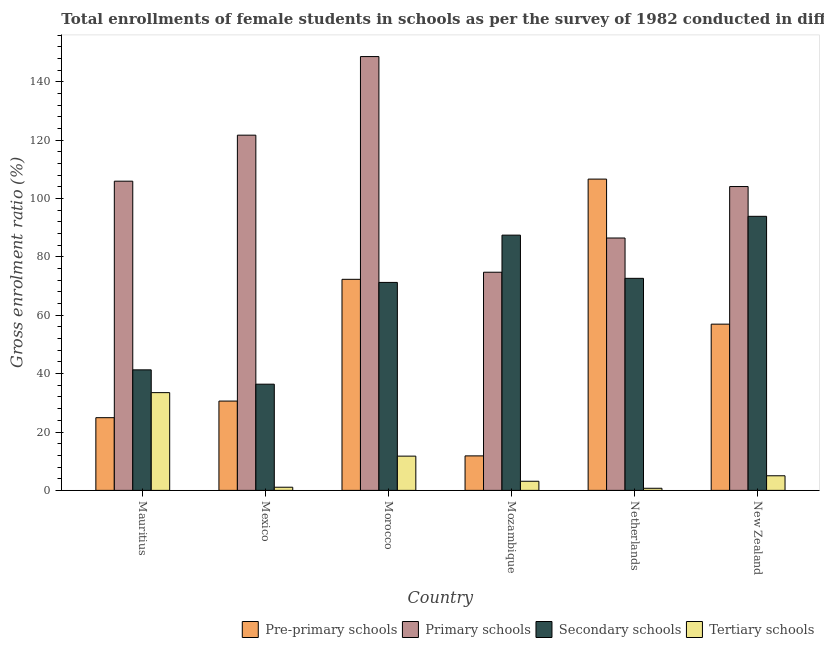How many groups of bars are there?
Offer a terse response. 6. Are the number of bars per tick equal to the number of legend labels?
Offer a very short reply. Yes. Are the number of bars on each tick of the X-axis equal?
Give a very brief answer. Yes. How many bars are there on the 6th tick from the left?
Your answer should be compact. 4. What is the label of the 5th group of bars from the left?
Your answer should be very brief. Netherlands. In how many cases, is the number of bars for a given country not equal to the number of legend labels?
Ensure brevity in your answer.  0. What is the gross enrolment ratio(female) in pre-primary schools in New Zealand?
Your answer should be compact. 56.95. Across all countries, what is the maximum gross enrolment ratio(female) in primary schools?
Keep it short and to the point. 148.61. Across all countries, what is the minimum gross enrolment ratio(female) in tertiary schools?
Give a very brief answer. 0.73. In which country was the gross enrolment ratio(female) in secondary schools maximum?
Keep it short and to the point. New Zealand. What is the total gross enrolment ratio(female) in secondary schools in the graph?
Provide a short and direct response. 402.89. What is the difference between the gross enrolment ratio(female) in secondary schools in Morocco and that in Netherlands?
Your answer should be compact. -1.4. What is the difference between the gross enrolment ratio(female) in secondary schools in New Zealand and the gross enrolment ratio(female) in tertiary schools in Mauritius?
Keep it short and to the point. 60.4. What is the average gross enrolment ratio(female) in pre-primary schools per country?
Offer a very short reply. 50.54. What is the difference between the gross enrolment ratio(female) in pre-primary schools and gross enrolment ratio(female) in tertiary schools in Mauritius?
Offer a very short reply. -8.58. What is the ratio of the gross enrolment ratio(female) in tertiary schools in Morocco to that in Netherlands?
Offer a very short reply. 16.17. Is the gross enrolment ratio(female) in secondary schools in Netherlands less than that in New Zealand?
Offer a very short reply. Yes. Is the difference between the gross enrolment ratio(female) in tertiary schools in Netherlands and New Zealand greater than the difference between the gross enrolment ratio(female) in secondary schools in Netherlands and New Zealand?
Keep it short and to the point. Yes. What is the difference between the highest and the second highest gross enrolment ratio(female) in pre-primary schools?
Your response must be concise. 34.33. What is the difference between the highest and the lowest gross enrolment ratio(female) in primary schools?
Make the answer very short. 73.88. Is the sum of the gross enrolment ratio(female) in primary schools in Mexico and Mozambique greater than the maximum gross enrolment ratio(female) in tertiary schools across all countries?
Keep it short and to the point. Yes. What does the 1st bar from the left in Mozambique represents?
Give a very brief answer. Pre-primary schools. What does the 1st bar from the right in New Zealand represents?
Ensure brevity in your answer.  Tertiary schools. Is it the case that in every country, the sum of the gross enrolment ratio(female) in pre-primary schools and gross enrolment ratio(female) in primary schools is greater than the gross enrolment ratio(female) in secondary schools?
Offer a terse response. No. How many countries are there in the graph?
Give a very brief answer. 6. Does the graph contain any zero values?
Offer a terse response. No. How many legend labels are there?
Provide a succinct answer. 4. How are the legend labels stacked?
Keep it short and to the point. Horizontal. What is the title of the graph?
Ensure brevity in your answer.  Total enrollments of female students in schools as per the survey of 1982 conducted in different countries. What is the Gross enrolment ratio (%) in Pre-primary schools in Mauritius?
Your response must be concise. 24.91. What is the Gross enrolment ratio (%) of Primary schools in Mauritius?
Your response must be concise. 105.93. What is the Gross enrolment ratio (%) in Secondary schools in Mauritius?
Make the answer very short. 41.29. What is the Gross enrolment ratio (%) of Tertiary schools in Mauritius?
Your answer should be very brief. 33.49. What is the Gross enrolment ratio (%) of Pre-primary schools in Mexico?
Your answer should be compact. 30.6. What is the Gross enrolment ratio (%) in Primary schools in Mexico?
Provide a short and direct response. 121.69. What is the Gross enrolment ratio (%) of Secondary schools in Mexico?
Your answer should be compact. 36.38. What is the Gross enrolment ratio (%) in Tertiary schools in Mexico?
Your answer should be very brief. 1.08. What is the Gross enrolment ratio (%) of Pre-primary schools in Morocco?
Your answer should be very brief. 72.31. What is the Gross enrolment ratio (%) in Primary schools in Morocco?
Offer a terse response. 148.61. What is the Gross enrolment ratio (%) of Secondary schools in Morocco?
Offer a terse response. 71.25. What is the Gross enrolment ratio (%) of Tertiary schools in Morocco?
Provide a succinct answer. 11.73. What is the Gross enrolment ratio (%) of Pre-primary schools in Mozambique?
Make the answer very short. 11.82. What is the Gross enrolment ratio (%) in Primary schools in Mozambique?
Make the answer very short. 74.73. What is the Gross enrolment ratio (%) of Secondary schools in Mozambique?
Offer a terse response. 87.44. What is the Gross enrolment ratio (%) in Tertiary schools in Mozambique?
Provide a short and direct response. 3.13. What is the Gross enrolment ratio (%) of Pre-primary schools in Netherlands?
Provide a succinct answer. 106.64. What is the Gross enrolment ratio (%) of Primary schools in Netherlands?
Your answer should be very brief. 86.46. What is the Gross enrolment ratio (%) of Secondary schools in Netherlands?
Provide a short and direct response. 72.64. What is the Gross enrolment ratio (%) of Tertiary schools in Netherlands?
Provide a short and direct response. 0.73. What is the Gross enrolment ratio (%) in Pre-primary schools in New Zealand?
Provide a short and direct response. 56.95. What is the Gross enrolment ratio (%) in Primary schools in New Zealand?
Offer a terse response. 104.09. What is the Gross enrolment ratio (%) in Secondary schools in New Zealand?
Offer a terse response. 93.89. What is the Gross enrolment ratio (%) in Tertiary schools in New Zealand?
Keep it short and to the point. 5.01. Across all countries, what is the maximum Gross enrolment ratio (%) of Pre-primary schools?
Your response must be concise. 106.64. Across all countries, what is the maximum Gross enrolment ratio (%) of Primary schools?
Your response must be concise. 148.61. Across all countries, what is the maximum Gross enrolment ratio (%) in Secondary schools?
Keep it short and to the point. 93.89. Across all countries, what is the maximum Gross enrolment ratio (%) in Tertiary schools?
Your response must be concise. 33.49. Across all countries, what is the minimum Gross enrolment ratio (%) in Pre-primary schools?
Ensure brevity in your answer.  11.82. Across all countries, what is the minimum Gross enrolment ratio (%) of Primary schools?
Provide a succinct answer. 74.73. Across all countries, what is the minimum Gross enrolment ratio (%) in Secondary schools?
Provide a short and direct response. 36.38. Across all countries, what is the minimum Gross enrolment ratio (%) in Tertiary schools?
Keep it short and to the point. 0.73. What is the total Gross enrolment ratio (%) in Pre-primary schools in the graph?
Provide a succinct answer. 303.22. What is the total Gross enrolment ratio (%) of Primary schools in the graph?
Provide a short and direct response. 641.52. What is the total Gross enrolment ratio (%) of Secondary schools in the graph?
Make the answer very short. 402.89. What is the total Gross enrolment ratio (%) in Tertiary schools in the graph?
Keep it short and to the point. 55.17. What is the difference between the Gross enrolment ratio (%) in Pre-primary schools in Mauritius and that in Mexico?
Your answer should be compact. -5.69. What is the difference between the Gross enrolment ratio (%) in Primary schools in Mauritius and that in Mexico?
Your response must be concise. -15.76. What is the difference between the Gross enrolment ratio (%) in Secondary schools in Mauritius and that in Mexico?
Make the answer very short. 4.91. What is the difference between the Gross enrolment ratio (%) of Tertiary schools in Mauritius and that in Mexico?
Provide a short and direct response. 32.41. What is the difference between the Gross enrolment ratio (%) of Pre-primary schools in Mauritius and that in Morocco?
Provide a succinct answer. -47.4. What is the difference between the Gross enrolment ratio (%) of Primary schools in Mauritius and that in Morocco?
Offer a terse response. -42.69. What is the difference between the Gross enrolment ratio (%) in Secondary schools in Mauritius and that in Morocco?
Your response must be concise. -29.95. What is the difference between the Gross enrolment ratio (%) in Tertiary schools in Mauritius and that in Morocco?
Ensure brevity in your answer.  21.75. What is the difference between the Gross enrolment ratio (%) in Pre-primary schools in Mauritius and that in Mozambique?
Your answer should be compact. 13.09. What is the difference between the Gross enrolment ratio (%) in Primary schools in Mauritius and that in Mozambique?
Offer a very short reply. 31.19. What is the difference between the Gross enrolment ratio (%) in Secondary schools in Mauritius and that in Mozambique?
Your answer should be compact. -46.15. What is the difference between the Gross enrolment ratio (%) of Tertiary schools in Mauritius and that in Mozambique?
Your response must be concise. 30.36. What is the difference between the Gross enrolment ratio (%) of Pre-primary schools in Mauritius and that in Netherlands?
Keep it short and to the point. -81.73. What is the difference between the Gross enrolment ratio (%) of Primary schools in Mauritius and that in Netherlands?
Provide a succinct answer. 19.47. What is the difference between the Gross enrolment ratio (%) of Secondary schools in Mauritius and that in Netherlands?
Give a very brief answer. -31.35. What is the difference between the Gross enrolment ratio (%) of Tertiary schools in Mauritius and that in Netherlands?
Give a very brief answer. 32.76. What is the difference between the Gross enrolment ratio (%) of Pre-primary schools in Mauritius and that in New Zealand?
Offer a terse response. -32.04. What is the difference between the Gross enrolment ratio (%) of Primary schools in Mauritius and that in New Zealand?
Provide a succinct answer. 1.84. What is the difference between the Gross enrolment ratio (%) of Secondary schools in Mauritius and that in New Zealand?
Give a very brief answer. -52.59. What is the difference between the Gross enrolment ratio (%) of Tertiary schools in Mauritius and that in New Zealand?
Offer a very short reply. 28.48. What is the difference between the Gross enrolment ratio (%) of Pre-primary schools in Mexico and that in Morocco?
Give a very brief answer. -41.71. What is the difference between the Gross enrolment ratio (%) of Primary schools in Mexico and that in Morocco?
Keep it short and to the point. -26.92. What is the difference between the Gross enrolment ratio (%) of Secondary schools in Mexico and that in Morocco?
Offer a very short reply. -34.86. What is the difference between the Gross enrolment ratio (%) of Tertiary schools in Mexico and that in Morocco?
Give a very brief answer. -10.65. What is the difference between the Gross enrolment ratio (%) in Pre-primary schools in Mexico and that in Mozambique?
Your response must be concise. 18.77. What is the difference between the Gross enrolment ratio (%) in Primary schools in Mexico and that in Mozambique?
Make the answer very short. 46.96. What is the difference between the Gross enrolment ratio (%) of Secondary schools in Mexico and that in Mozambique?
Offer a terse response. -51.06. What is the difference between the Gross enrolment ratio (%) in Tertiary schools in Mexico and that in Mozambique?
Give a very brief answer. -2.05. What is the difference between the Gross enrolment ratio (%) of Pre-primary schools in Mexico and that in Netherlands?
Keep it short and to the point. -76.04. What is the difference between the Gross enrolment ratio (%) of Primary schools in Mexico and that in Netherlands?
Make the answer very short. 35.24. What is the difference between the Gross enrolment ratio (%) in Secondary schools in Mexico and that in Netherlands?
Give a very brief answer. -36.26. What is the difference between the Gross enrolment ratio (%) of Tertiary schools in Mexico and that in Netherlands?
Ensure brevity in your answer.  0.36. What is the difference between the Gross enrolment ratio (%) in Pre-primary schools in Mexico and that in New Zealand?
Your answer should be very brief. -26.35. What is the difference between the Gross enrolment ratio (%) in Primary schools in Mexico and that in New Zealand?
Give a very brief answer. 17.6. What is the difference between the Gross enrolment ratio (%) of Secondary schools in Mexico and that in New Zealand?
Your answer should be compact. -57.5. What is the difference between the Gross enrolment ratio (%) of Tertiary schools in Mexico and that in New Zealand?
Offer a terse response. -3.93. What is the difference between the Gross enrolment ratio (%) in Pre-primary schools in Morocco and that in Mozambique?
Offer a very short reply. 60.49. What is the difference between the Gross enrolment ratio (%) in Primary schools in Morocco and that in Mozambique?
Provide a succinct answer. 73.88. What is the difference between the Gross enrolment ratio (%) of Secondary schools in Morocco and that in Mozambique?
Give a very brief answer. -16.2. What is the difference between the Gross enrolment ratio (%) in Tertiary schools in Morocco and that in Mozambique?
Keep it short and to the point. 8.6. What is the difference between the Gross enrolment ratio (%) of Pre-primary schools in Morocco and that in Netherlands?
Offer a terse response. -34.33. What is the difference between the Gross enrolment ratio (%) of Primary schools in Morocco and that in Netherlands?
Offer a very short reply. 62.16. What is the difference between the Gross enrolment ratio (%) in Secondary schools in Morocco and that in Netherlands?
Offer a terse response. -1.4. What is the difference between the Gross enrolment ratio (%) of Tertiary schools in Morocco and that in Netherlands?
Provide a succinct answer. 11.01. What is the difference between the Gross enrolment ratio (%) in Pre-primary schools in Morocco and that in New Zealand?
Your response must be concise. 15.36. What is the difference between the Gross enrolment ratio (%) in Primary schools in Morocco and that in New Zealand?
Your response must be concise. 44.52. What is the difference between the Gross enrolment ratio (%) in Secondary schools in Morocco and that in New Zealand?
Ensure brevity in your answer.  -22.64. What is the difference between the Gross enrolment ratio (%) of Tertiary schools in Morocco and that in New Zealand?
Your answer should be very brief. 6.72. What is the difference between the Gross enrolment ratio (%) of Pre-primary schools in Mozambique and that in Netherlands?
Ensure brevity in your answer.  -94.81. What is the difference between the Gross enrolment ratio (%) in Primary schools in Mozambique and that in Netherlands?
Your answer should be very brief. -11.72. What is the difference between the Gross enrolment ratio (%) in Secondary schools in Mozambique and that in Netherlands?
Offer a terse response. 14.8. What is the difference between the Gross enrolment ratio (%) in Tertiary schools in Mozambique and that in Netherlands?
Your response must be concise. 2.4. What is the difference between the Gross enrolment ratio (%) of Pre-primary schools in Mozambique and that in New Zealand?
Keep it short and to the point. -45.13. What is the difference between the Gross enrolment ratio (%) of Primary schools in Mozambique and that in New Zealand?
Offer a very short reply. -29.36. What is the difference between the Gross enrolment ratio (%) of Secondary schools in Mozambique and that in New Zealand?
Give a very brief answer. -6.44. What is the difference between the Gross enrolment ratio (%) of Tertiary schools in Mozambique and that in New Zealand?
Keep it short and to the point. -1.88. What is the difference between the Gross enrolment ratio (%) in Pre-primary schools in Netherlands and that in New Zealand?
Offer a very short reply. 49.68. What is the difference between the Gross enrolment ratio (%) of Primary schools in Netherlands and that in New Zealand?
Provide a short and direct response. -17.64. What is the difference between the Gross enrolment ratio (%) of Secondary schools in Netherlands and that in New Zealand?
Provide a short and direct response. -21.24. What is the difference between the Gross enrolment ratio (%) in Tertiary schools in Netherlands and that in New Zealand?
Your answer should be compact. -4.28. What is the difference between the Gross enrolment ratio (%) in Pre-primary schools in Mauritius and the Gross enrolment ratio (%) in Primary schools in Mexico?
Your answer should be very brief. -96.78. What is the difference between the Gross enrolment ratio (%) of Pre-primary schools in Mauritius and the Gross enrolment ratio (%) of Secondary schools in Mexico?
Provide a short and direct response. -11.47. What is the difference between the Gross enrolment ratio (%) in Pre-primary schools in Mauritius and the Gross enrolment ratio (%) in Tertiary schools in Mexico?
Provide a short and direct response. 23.83. What is the difference between the Gross enrolment ratio (%) in Primary schools in Mauritius and the Gross enrolment ratio (%) in Secondary schools in Mexico?
Keep it short and to the point. 69.55. What is the difference between the Gross enrolment ratio (%) in Primary schools in Mauritius and the Gross enrolment ratio (%) in Tertiary schools in Mexico?
Provide a succinct answer. 104.85. What is the difference between the Gross enrolment ratio (%) of Secondary schools in Mauritius and the Gross enrolment ratio (%) of Tertiary schools in Mexico?
Offer a very short reply. 40.21. What is the difference between the Gross enrolment ratio (%) in Pre-primary schools in Mauritius and the Gross enrolment ratio (%) in Primary schools in Morocco?
Offer a terse response. -123.7. What is the difference between the Gross enrolment ratio (%) in Pre-primary schools in Mauritius and the Gross enrolment ratio (%) in Secondary schools in Morocco?
Your response must be concise. -46.34. What is the difference between the Gross enrolment ratio (%) of Pre-primary schools in Mauritius and the Gross enrolment ratio (%) of Tertiary schools in Morocco?
Offer a very short reply. 13.18. What is the difference between the Gross enrolment ratio (%) of Primary schools in Mauritius and the Gross enrolment ratio (%) of Secondary schools in Morocco?
Your answer should be very brief. 34.68. What is the difference between the Gross enrolment ratio (%) in Primary schools in Mauritius and the Gross enrolment ratio (%) in Tertiary schools in Morocco?
Your answer should be compact. 94.19. What is the difference between the Gross enrolment ratio (%) in Secondary schools in Mauritius and the Gross enrolment ratio (%) in Tertiary schools in Morocco?
Keep it short and to the point. 29.56. What is the difference between the Gross enrolment ratio (%) in Pre-primary schools in Mauritius and the Gross enrolment ratio (%) in Primary schools in Mozambique?
Provide a short and direct response. -49.82. What is the difference between the Gross enrolment ratio (%) in Pre-primary schools in Mauritius and the Gross enrolment ratio (%) in Secondary schools in Mozambique?
Provide a succinct answer. -62.53. What is the difference between the Gross enrolment ratio (%) in Pre-primary schools in Mauritius and the Gross enrolment ratio (%) in Tertiary schools in Mozambique?
Make the answer very short. 21.78. What is the difference between the Gross enrolment ratio (%) in Primary schools in Mauritius and the Gross enrolment ratio (%) in Secondary schools in Mozambique?
Your response must be concise. 18.49. What is the difference between the Gross enrolment ratio (%) of Primary schools in Mauritius and the Gross enrolment ratio (%) of Tertiary schools in Mozambique?
Keep it short and to the point. 102.8. What is the difference between the Gross enrolment ratio (%) of Secondary schools in Mauritius and the Gross enrolment ratio (%) of Tertiary schools in Mozambique?
Offer a very short reply. 38.16. What is the difference between the Gross enrolment ratio (%) in Pre-primary schools in Mauritius and the Gross enrolment ratio (%) in Primary schools in Netherlands?
Provide a succinct answer. -61.55. What is the difference between the Gross enrolment ratio (%) in Pre-primary schools in Mauritius and the Gross enrolment ratio (%) in Secondary schools in Netherlands?
Your answer should be compact. -47.73. What is the difference between the Gross enrolment ratio (%) of Pre-primary schools in Mauritius and the Gross enrolment ratio (%) of Tertiary schools in Netherlands?
Make the answer very short. 24.18. What is the difference between the Gross enrolment ratio (%) in Primary schools in Mauritius and the Gross enrolment ratio (%) in Secondary schools in Netherlands?
Give a very brief answer. 33.29. What is the difference between the Gross enrolment ratio (%) in Primary schools in Mauritius and the Gross enrolment ratio (%) in Tertiary schools in Netherlands?
Make the answer very short. 105.2. What is the difference between the Gross enrolment ratio (%) in Secondary schools in Mauritius and the Gross enrolment ratio (%) in Tertiary schools in Netherlands?
Make the answer very short. 40.57. What is the difference between the Gross enrolment ratio (%) in Pre-primary schools in Mauritius and the Gross enrolment ratio (%) in Primary schools in New Zealand?
Your answer should be compact. -79.18. What is the difference between the Gross enrolment ratio (%) of Pre-primary schools in Mauritius and the Gross enrolment ratio (%) of Secondary schools in New Zealand?
Your answer should be compact. -68.98. What is the difference between the Gross enrolment ratio (%) in Pre-primary schools in Mauritius and the Gross enrolment ratio (%) in Tertiary schools in New Zealand?
Provide a short and direct response. 19.9. What is the difference between the Gross enrolment ratio (%) in Primary schools in Mauritius and the Gross enrolment ratio (%) in Secondary schools in New Zealand?
Ensure brevity in your answer.  12.04. What is the difference between the Gross enrolment ratio (%) of Primary schools in Mauritius and the Gross enrolment ratio (%) of Tertiary schools in New Zealand?
Your response must be concise. 100.92. What is the difference between the Gross enrolment ratio (%) of Secondary schools in Mauritius and the Gross enrolment ratio (%) of Tertiary schools in New Zealand?
Your answer should be very brief. 36.29. What is the difference between the Gross enrolment ratio (%) of Pre-primary schools in Mexico and the Gross enrolment ratio (%) of Primary schools in Morocco?
Make the answer very short. -118.02. What is the difference between the Gross enrolment ratio (%) in Pre-primary schools in Mexico and the Gross enrolment ratio (%) in Secondary schools in Morocco?
Your response must be concise. -40.65. What is the difference between the Gross enrolment ratio (%) of Pre-primary schools in Mexico and the Gross enrolment ratio (%) of Tertiary schools in Morocco?
Provide a short and direct response. 18.86. What is the difference between the Gross enrolment ratio (%) in Primary schools in Mexico and the Gross enrolment ratio (%) in Secondary schools in Morocco?
Provide a short and direct response. 50.45. What is the difference between the Gross enrolment ratio (%) of Primary schools in Mexico and the Gross enrolment ratio (%) of Tertiary schools in Morocco?
Ensure brevity in your answer.  109.96. What is the difference between the Gross enrolment ratio (%) in Secondary schools in Mexico and the Gross enrolment ratio (%) in Tertiary schools in Morocco?
Make the answer very short. 24.65. What is the difference between the Gross enrolment ratio (%) of Pre-primary schools in Mexico and the Gross enrolment ratio (%) of Primary schools in Mozambique?
Keep it short and to the point. -44.14. What is the difference between the Gross enrolment ratio (%) of Pre-primary schools in Mexico and the Gross enrolment ratio (%) of Secondary schools in Mozambique?
Your answer should be very brief. -56.85. What is the difference between the Gross enrolment ratio (%) in Pre-primary schools in Mexico and the Gross enrolment ratio (%) in Tertiary schools in Mozambique?
Your answer should be very brief. 27.47. What is the difference between the Gross enrolment ratio (%) in Primary schools in Mexico and the Gross enrolment ratio (%) in Secondary schools in Mozambique?
Ensure brevity in your answer.  34.25. What is the difference between the Gross enrolment ratio (%) in Primary schools in Mexico and the Gross enrolment ratio (%) in Tertiary schools in Mozambique?
Keep it short and to the point. 118.56. What is the difference between the Gross enrolment ratio (%) in Secondary schools in Mexico and the Gross enrolment ratio (%) in Tertiary schools in Mozambique?
Provide a short and direct response. 33.25. What is the difference between the Gross enrolment ratio (%) of Pre-primary schools in Mexico and the Gross enrolment ratio (%) of Primary schools in Netherlands?
Make the answer very short. -55.86. What is the difference between the Gross enrolment ratio (%) in Pre-primary schools in Mexico and the Gross enrolment ratio (%) in Secondary schools in Netherlands?
Your answer should be very brief. -42.05. What is the difference between the Gross enrolment ratio (%) in Pre-primary schools in Mexico and the Gross enrolment ratio (%) in Tertiary schools in Netherlands?
Provide a succinct answer. 29.87. What is the difference between the Gross enrolment ratio (%) of Primary schools in Mexico and the Gross enrolment ratio (%) of Secondary schools in Netherlands?
Keep it short and to the point. 49.05. What is the difference between the Gross enrolment ratio (%) of Primary schools in Mexico and the Gross enrolment ratio (%) of Tertiary schools in Netherlands?
Offer a very short reply. 120.97. What is the difference between the Gross enrolment ratio (%) in Secondary schools in Mexico and the Gross enrolment ratio (%) in Tertiary schools in Netherlands?
Provide a short and direct response. 35.66. What is the difference between the Gross enrolment ratio (%) in Pre-primary schools in Mexico and the Gross enrolment ratio (%) in Primary schools in New Zealand?
Give a very brief answer. -73.5. What is the difference between the Gross enrolment ratio (%) in Pre-primary schools in Mexico and the Gross enrolment ratio (%) in Secondary schools in New Zealand?
Keep it short and to the point. -63.29. What is the difference between the Gross enrolment ratio (%) of Pre-primary schools in Mexico and the Gross enrolment ratio (%) of Tertiary schools in New Zealand?
Your answer should be compact. 25.59. What is the difference between the Gross enrolment ratio (%) in Primary schools in Mexico and the Gross enrolment ratio (%) in Secondary schools in New Zealand?
Your answer should be very brief. 27.81. What is the difference between the Gross enrolment ratio (%) in Primary schools in Mexico and the Gross enrolment ratio (%) in Tertiary schools in New Zealand?
Provide a succinct answer. 116.68. What is the difference between the Gross enrolment ratio (%) in Secondary schools in Mexico and the Gross enrolment ratio (%) in Tertiary schools in New Zealand?
Provide a succinct answer. 31.37. What is the difference between the Gross enrolment ratio (%) in Pre-primary schools in Morocco and the Gross enrolment ratio (%) in Primary schools in Mozambique?
Give a very brief answer. -2.43. What is the difference between the Gross enrolment ratio (%) of Pre-primary schools in Morocco and the Gross enrolment ratio (%) of Secondary schools in Mozambique?
Provide a short and direct response. -15.13. What is the difference between the Gross enrolment ratio (%) of Pre-primary schools in Morocco and the Gross enrolment ratio (%) of Tertiary schools in Mozambique?
Provide a succinct answer. 69.18. What is the difference between the Gross enrolment ratio (%) of Primary schools in Morocco and the Gross enrolment ratio (%) of Secondary schools in Mozambique?
Your answer should be compact. 61.17. What is the difference between the Gross enrolment ratio (%) of Primary schools in Morocco and the Gross enrolment ratio (%) of Tertiary schools in Mozambique?
Provide a short and direct response. 145.48. What is the difference between the Gross enrolment ratio (%) of Secondary schools in Morocco and the Gross enrolment ratio (%) of Tertiary schools in Mozambique?
Your response must be concise. 68.12. What is the difference between the Gross enrolment ratio (%) in Pre-primary schools in Morocco and the Gross enrolment ratio (%) in Primary schools in Netherlands?
Your response must be concise. -14.15. What is the difference between the Gross enrolment ratio (%) in Pre-primary schools in Morocco and the Gross enrolment ratio (%) in Secondary schools in Netherlands?
Make the answer very short. -0.33. What is the difference between the Gross enrolment ratio (%) in Pre-primary schools in Morocco and the Gross enrolment ratio (%) in Tertiary schools in Netherlands?
Your answer should be very brief. 71.58. What is the difference between the Gross enrolment ratio (%) in Primary schools in Morocco and the Gross enrolment ratio (%) in Secondary schools in Netherlands?
Make the answer very short. 75.97. What is the difference between the Gross enrolment ratio (%) of Primary schools in Morocco and the Gross enrolment ratio (%) of Tertiary schools in Netherlands?
Keep it short and to the point. 147.89. What is the difference between the Gross enrolment ratio (%) in Secondary schools in Morocco and the Gross enrolment ratio (%) in Tertiary schools in Netherlands?
Your answer should be compact. 70.52. What is the difference between the Gross enrolment ratio (%) in Pre-primary schools in Morocco and the Gross enrolment ratio (%) in Primary schools in New Zealand?
Your answer should be compact. -31.78. What is the difference between the Gross enrolment ratio (%) in Pre-primary schools in Morocco and the Gross enrolment ratio (%) in Secondary schools in New Zealand?
Make the answer very short. -21.58. What is the difference between the Gross enrolment ratio (%) of Pre-primary schools in Morocco and the Gross enrolment ratio (%) of Tertiary schools in New Zealand?
Offer a terse response. 67.3. What is the difference between the Gross enrolment ratio (%) of Primary schools in Morocco and the Gross enrolment ratio (%) of Secondary schools in New Zealand?
Keep it short and to the point. 54.73. What is the difference between the Gross enrolment ratio (%) of Primary schools in Morocco and the Gross enrolment ratio (%) of Tertiary schools in New Zealand?
Offer a very short reply. 143.61. What is the difference between the Gross enrolment ratio (%) of Secondary schools in Morocco and the Gross enrolment ratio (%) of Tertiary schools in New Zealand?
Provide a short and direct response. 66.24. What is the difference between the Gross enrolment ratio (%) in Pre-primary schools in Mozambique and the Gross enrolment ratio (%) in Primary schools in Netherlands?
Make the answer very short. -74.63. What is the difference between the Gross enrolment ratio (%) of Pre-primary schools in Mozambique and the Gross enrolment ratio (%) of Secondary schools in Netherlands?
Keep it short and to the point. -60.82. What is the difference between the Gross enrolment ratio (%) in Pre-primary schools in Mozambique and the Gross enrolment ratio (%) in Tertiary schools in Netherlands?
Provide a short and direct response. 11.1. What is the difference between the Gross enrolment ratio (%) in Primary schools in Mozambique and the Gross enrolment ratio (%) in Secondary schools in Netherlands?
Offer a very short reply. 2.09. What is the difference between the Gross enrolment ratio (%) in Primary schools in Mozambique and the Gross enrolment ratio (%) in Tertiary schools in Netherlands?
Your response must be concise. 74.01. What is the difference between the Gross enrolment ratio (%) in Secondary schools in Mozambique and the Gross enrolment ratio (%) in Tertiary schools in Netherlands?
Offer a very short reply. 86.72. What is the difference between the Gross enrolment ratio (%) of Pre-primary schools in Mozambique and the Gross enrolment ratio (%) of Primary schools in New Zealand?
Give a very brief answer. -92.27. What is the difference between the Gross enrolment ratio (%) of Pre-primary schools in Mozambique and the Gross enrolment ratio (%) of Secondary schools in New Zealand?
Provide a succinct answer. -82.06. What is the difference between the Gross enrolment ratio (%) of Pre-primary schools in Mozambique and the Gross enrolment ratio (%) of Tertiary schools in New Zealand?
Your answer should be very brief. 6.81. What is the difference between the Gross enrolment ratio (%) of Primary schools in Mozambique and the Gross enrolment ratio (%) of Secondary schools in New Zealand?
Provide a succinct answer. -19.15. What is the difference between the Gross enrolment ratio (%) in Primary schools in Mozambique and the Gross enrolment ratio (%) in Tertiary schools in New Zealand?
Offer a terse response. 69.72. What is the difference between the Gross enrolment ratio (%) of Secondary schools in Mozambique and the Gross enrolment ratio (%) of Tertiary schools in New Zealand?
Provide a short and direct response. 82.43. What is the difference between the Gross enrolment ratio (%) in Pre-primary schools in Netherlands and the Gross enrolment ratio (%) in Primary schools in New Zealand?
Your answer should be very brief. 2.54. What is the difference between the Gross enrolment ratio (%) of Pre-primary schools in Netherlands and the Gross enrolment ratio (%) of Secondary schools in New Zealand?
Your answer should be compact. 12.75. What is the difference between the Gross enrolment ratio (%) of Pre-primary schools in Netherlands and the Gross enrolment ratio (%) of Tertiary schools in New Zealand?
Provide a short and direct response. 101.63. What is the difference between the Gross enrolment ratio (%) of Primary schools in Netherlands and the Gross enrolment ratio (%) of Secondary schools in New Zealand?
Keep it short and to the point. -7.43. What is the difference between the Gross enrolment ratio (%) in Primary schools in Netherlands and the Gross enrolment ratio (%) in Tertiary schools in New Zealand?
Your response must be concise. 81.45. What is the difference between the Gross enrolment ratio (%) of Secondary schools in Netherlands and the Gross enrolment ratio (%) of Tertiary schools in New Zealand?
Make the answer very short. 67.63. What is the average Gross enrolment ratio (%) of Pre-primary schools per country?
Provide a short and direct response. 50.54. What is the average Gross enrolment ratio (%) in Primary schools per country?
Your answer should be compact. 106.92. What is the average Gross enrolment ratio (%) of Secondary schools per country?
Keep it short and to the point. 67.15. What is the average Gross enrolment ratio (%) of Tertiary schools per country?
Ensure brevity in your answer.  9.2. What is the difference between the Gross enrolment ratio (%) of Pre-primary schools and Gross enrolment ratio (%) of Primary schools in Mauritius?
Make the answer very short. -81.02. What is the difference between the Gross enrolment ratio (%) in Pre-primary schools and Gross enrolment ratio (%) in Secondary schools in Mauritius?
Ensure brevity in your answer.  -16.38. What is the difference between the Gross enrolment ratio (%) in Pre-primary schools and Gross enrolment ratio (%) in Tertiary schools in Mauritius?
Your answer should be compact. -8.58. What is the difference between the Gross enrolment ratio (%) in Primary schools and Gross enrolment ratio (%) in Secondary schools in Mauritius?
Provide a succinct answer. 64.63. What is the difference between the Gross enrolment ratio (%) in Primary schools and Gross enrolment ratio (%) in Tertiary schools in Mauritius?
Your answer should be very brief. 72.44. What is the difference between the Gross enrolment ratio (%) in Secondary schools and Gross enrolment ratio (%) in Tertiary schools in Mauritius?
Your answer should be compact. 7.81. What is the difference between the Gross enrolment ratio (%) of Pre-primary schools and Gross enrolment ratio (%) of Primary schools in Mexico?
Your answer should be compact. -91.1. What is the difference between the Gross enrolment ratio (%) in Pre-primary schools and Gross enrolment ratio (%) in Secondary schools in Mexico?
Your answer should be compact. -5.79. What is the difference between the Gross enrolment ratio (%) of Pre-primary schools and Gross enrolment ratio (%) of Tertiary schools in Mexico?
Ensure brevity in your answer.  29.51. What is the difference between the Gross enrolment ratio (%) of Primary schools and Gross enrolment ratio (%) of Secondary schools in Mexico?
Ensure brevity in your answer.  85.31. What is the difference between the Gross enrolment ratio (%) of Primary schools and Gross enrolment ratio (%) of Tertiary schools in Mexico?
Offer a very short reply. 120.61. What is the difference between the Gross enrolment ratio (%) of Secondary schools and Gross enrolment ratio (%) of Tertiary schools in Mexico?
Provide a succinct answer. 35.3. What is the difference between the Gross enrolment ratio (%) in Pre-primary schools and Gross enrolment ratio (%) in Primary schools in Morocco?
Offer a terse response. -76.31. What is the difference between the Gross enrolment ratio (%) of Pre-primary schools and Gross enrolment ratio (%) of Secondary schools in Morocco?
Offer a very short reply. 1.06. What is the difference between the Gross enrolment ratio (%) of Pre-primary schools and Gross enrolment ratio (%) of Tertiary schools in Morocco?
Offer a terse response. 60.57. What is the difference between the Gross enrolment ratio (%) of Primary schools and Gross enrolment ratio (%) of Secondary schools in Morocco?
Make the answer very short. 77.37. What is the difference between the Gross enrolment ratio (%) of Primary schools and Gross enrolment ratio (%) of Tertiary schools in Morocco?
Your response must be concise. 136.88. What is the difference between the Gross enrolment ratio (%) in Secondary schools and Gross enrolment ratio (%) in Tertiary schools in Morocco?
Your answer should be compact. 59.51. What is the difference between the Gross enrolment ratio (%) in Pre-primary schools and Gross enrolment ratio (%) in Primary schools in Mozambique?
Your response must be concise. -62.91. What is the difference between the Gross enrolment ratio (%) in Pre-primary schools and Gross enrolment ratio (%) in Secondary schools in Mozambique?
Offer a very short reply. -75.62. What is the difference between the Gross enrolment ratio (%) of Pre-primary schools and Gross enrolment ratio (%) of Tertiary schools in Mozambique?
Provide a succinct answer. 8.69. What is the difference between the Gross enrolment ratio (%) of Primary schools and Gross enrolment ratio (%) of Secondary schools in Mozambique?
Your answer should be very brief. -12.71. What is the difference between the Gross enrolment ratio (%) of Primary schools and Gross enrolment ratio (%) of Tertiary schools in Mozambique?
Offer a terse response. 71.6. What is the difference between the Gross enrolment ratio (%) in Secondary schools and Gross enrolment ratio (%) in Tertiary schools in Mozambique?
Offer a very short reply. 84.31. What is the difference between the Gross enrolment ratio (%) in Pre-primary schools and Gross enrolment ratio (%) in Primary schools in Netherlands?
Ensure brevity in your answer.  20.18. What is the difference between the Gross enrolment ratio (%) of Pre-primary schools and Gross enrolment ratio (%) of Secondary schools in Netherlands?
Keep it short and to the point. 33.99. What is the difference between the Gross enrolment ratio (%) of Pre-primary schools and Gross enrolment ratio (%) of Tertiary schools in Netherlands?
Your answer should be compact. 105.91. What is the difference between the Gross enrolment ratio (%) of Primary schools and Gross enrolment ratio (%) of Secondary schools in Netherlands?
Offer a terse response. 13.81. What is the difference between the Gross enrolment ratio (%) in Primary schools and Gross enrolment ratio (%) in Tertiary schools in Netherlands?
Your response must be concise. 85.73. What is the difference between the Gross enrolment ratio (%) in Secondary schools and Gross enrolment ratio (%) in Tertiary schools in Netherlands?
Ensure brevity in your answer.  71.92. What is the difference between the Gross enrolment ratio (%) of Pre-primary schools and Gross enrolment ratio (%) of Primary schools in New Zealand?
Ensure brevity in your answer.  -47.14. What is the difference between the Gross enrolment ratio (%) in Pre-primary schools and Gross enrolment ratio (%) in Secondary schools in New Zealand?
Your answer should be compact. -36.94. What is the difference between the Gross enrolment ratio (%) of Pre-primary schools and Gross enrolment ratio (%) of Tertiary schools in New Zealand?
Your answer should be very brief. 51.94. What is the difference between the Gross enrolment ratio (%) in Primary schools and Gross enrolment ratio (%) in Secondary schools in New Zealand?
Provide a short and direct response. 10.21. What is the difference between the Gross enrolment ratio (%) of Primary schools and Gross enrolment ratio (%) of Tertiary schools in New Zealand?
Your answer should be compact. 99.08. What is the difference between the Gross enrolment ratio (%) in Secondary schools and Gross enrolment ratio (%) in Tertiary schools in New Zealand?
Make the answer very short. 88.88. What is the ratio of the Gross enrolment ratio (%) in Pre-primary schools in Mauritius to that in Mexico?
Offer a terse response. 0.81. What is the ratio of the Gross enrolment ratio (%) of Primary schools in Mauritius to that in Mexico?
Your response must be concise. 0.87. What is the ratio of the Gross enrolment ratio (%) of Secondary schools in Mauritius to that in Mexico?
Your answer should be compact. 1.14. What is the ratio of the Gross enrolment ratio (%) of Tertiary schools in Mauritius to that in Mexico?
Provide a short and direct response. 30.94. What is the ratio of the Gross enrolment ratio (%) in Pre-primary schools in Mauritius to that in Morocco?
Your answer should be very brief. 0.34. What is the ratio of the Gross enrolment ratio (%) in Primary schools in Mauritius to that in Morocco?
Make the answer very short. 0.71. What is the ratio of the Gross enrolment ratio (%) in Secondary schools in Mauritius to that in Morocco?
Provide a succinct answer. 0.58. What is the ratio of the Gross enrolment ratio (%) of Tertiary schools in Mauritius to that in Morocco?
Offer a very short reply. 2.85. What is the ratio of the Gross enrolment ratio (%) of Pre-primary schools in Mauritius to that in Mozambique?
Offer a terse response. 2.11. What is the ratio of the Gross enrolment ratio (%) in Primary schools in Mauritius to that in Mozambique?
Your response must be concise. 1.42. What is the ratio of the Gross enrolment ratio (%) in Secondary schools in Mauritius to that in Mozambique?
Your answer should be very brief. 0.47. What is the ratio of the Gross enrolment ratio (%) of Tertiary schools in Mauritius to that in Mozambique?
Make the answer very short. 10.7. What is the ratio of the Gross enrolment ratio (%) of Pre-primary schools in Mauritius to that in Netherlands?
Ensure brevity in your answer.  0.23. What is the ratio of the Gross enrolment ratio (%) in Primary schools in Mauritius to that in Netherlands?
Offer a terse response. 1.23. What is the ratio of the Gross enrolment ratio (%) of Secondary schools in Mauritius to that in Netherlands?
Provide a short and direct response. 0.57. What is the ratio of the Gross enrolment ratio (%) of Tertiary schools in Mauritius to that in Netherlands?
Keep it short and to the point. 46.14. What is the ratio of the Gross enrolment ratio (%) in Pre-primary schools in Mauritius to that in New Zealand?
Offer a terse response. 0.44. What is the ratio of the Gross enrolment ratio (%) in Primary schools in Mauritius to that in New Zealand?
Provide a succinct answer. 1.02. What is the ratio of the Gross enrolment ratio (%) in Secondary schools in Mauritius to that in New Zealand?
Make the answer very short. 0.44. What is the ratio of the Gross enrolment ratio (%) in Tertiary schools in Mauritius to that in New Zealand?
Provide a short and direct response. 6.69. What is the ratio of the Gross enrolment ratio (%) of Pre-primary schools in Mexico to that in Morocco?
Your response must be concise. 0.42. What is the ratio of the Gross enrolment ratio (%) of Primary schools in Mexico to that in Morocco?
Offer a very short reply. 0.82. What is the ratio of the Gross enrolment ratio (%) of Secondary schools in Mexico to that in Morocco?
Offer a terse response. 0.51. What is the ratio of the Gross enrolment ratio (%) in Tertiary schools in Mexico to that in Morocco?
Make the answer very short. 0.09. What is the ratio of the Gross enrolment ratio (%) of Pre-primary schools in Mexico to that in Mozambique?
Ensure brevity in your answer.  2.59. What is the ratio of the Gross enrolment ratio (%) in Primary schools in Mexico to that in Mozambique?
Ensure brevity in your answer.  1.63. What is the ratio of the Gross enrolment ratio (%) in Secondary schools in Mexico to that in Mozambique?
Ensure brevity in your answer.  0.42. What is the ratio of the Gross enrolment ratio (%) in Tertiary schools in Mexico to that in Mozambique?
Your answer should be very brief. 0.35. What is the ratio of the Gross enrolment ratio (%) in Pre-primary schools in Mexico to that in Netherlands?
Offer a very short reply. 0.29. What is the ratio of the Gross enrolment ratio (%) in Primary schools in Mexico to that in Netherlands?
Your answer should be very brief. 1.41. What is the ratio of the Gross enrolment ratio (%) in Secondary schools in Mexico to that in Netherlands?
Offer a very short reply. 0.5. What is the ratio of the Gross enrolment ratio (%) in Tertiary schools in Mexico to that in Netherlands?
Your answer should be compact. 1.49. What is the ratio of the Gross enrolment ratio (%) in Pre-primary schools in Mexico to that in New Zealand?
Provide a succinct answer. 0.54. What is the ratio of the Gross enrolment ratio (%) of Primary schools in Mexico to that in New Zealand?
Your response must be concise. 1.17. What is the ratio of the Gross enrolment ratio (%) in Secondary schools in Mexico to that in New Zealand?
Your response must be concise. 0.39. What is the ratio of the Gross enrolment ratio (%) in Tertiary schools in Mexico to that in New Zealand?
Make the answer very short. 0.22. What is the ratio of the Gross enrolment ratio (%) of Pre-primary schools in Morocco to that in Mozambique?
Provide a short and direct response. 6.12. What is the ratio of the Gross enrolment ratio (%) in Primary schools in Morocco to that in Mozambique?
Offer a very short reply. 1.99. What is the ratio of the Gross enrolment ratio (%) in Secondary schools in Morocco to that in Mozambique?
Provide a succinct answer. 0.81. What is the ratio of the Gross enrolment ratio (%) in Tertiary schools in Morocco to that in Mozambique?
Ensure brevity in your answer.  3.75. What is the ratio of the Gross enrolment ratio (%) in Pre-primary schools in Morocco to that in Netherlands?
Make the answer very short. 0.68. What is the ratio of the Gross enrolment ratio (%) of Primary schools in Morocco to that in Netherlands?
Offer a terse response. 1.72. What is the ratio of the Gross enrolment ratio (%) of Secondary schools in Morocco to that in Netherlands?
Offer a terse response. 0.98. What is the ratio of the Gross enrolment ratio (%) of Tertiary schools in Morocco to that in Netherlands?
Give a very brief answer. 16.17. What is the ratio of the Gross enrolment ratio (%) in Pre-primary schools in Morocco to that in New Zealand?
Offer a very short reply. 1.27. What is the ratio of the Gross enrolment ratio (%) of Primary schools in Morocco to that in New Zealand?
Ensure brevity in your answer.  1.43. What is the ratio of the Gross enrolment ratio (%) of Secondary schools in Morocco to that in New Zealand?
Keep it short and to the point. 0.76. What is the ratio of the Gross enrolment ratio (%) in Tertiary schools in Morocco to that in New Zealand?
Keep it short and to the point. 2.34. What is the ratio of the Gross enrolment ratio (%) in Pre-primary schools in Mozambique to that in Netherlands?
Make the answer very short. 0.11. What is the ratio of the Gross enrolment ratio (%) in Primary schools in Mozambique to that in Netherlands?
Make the answer very short. 0.86. What is the ratio of the Gross enrolment ratio (%) in Secondary schools in Mozambique to that in Netherlands?
Ensure brevity in your answer.  1.2. What is the ratio of the Gross enrolment ratio (%) of Tertiary schools in Mozambique to that in Netherlands?
Your answer should be very brief. 4.31. What is the ratio of the Gross enrolment ratio (%) of Pre-primary schools in Mozambique to that in New Zealand?
Keep it short and to the point. 0.21. What is the ratio of the Gross enrolment ratio (%) of Primary schools in Mozambique to that in New Zealand?
Ensure brevity in your answer.  0.72. What is the ratio of the Gross enrolment ratio (%) of Secondary schools in Mozambique to that in New Zealand?
Offer a terse response. 0.93. What is the ratio of the Gross enrolment ratio (%) of Tertiary schools in Mozambique to that in New Zealand?
Your answer should be compact. 0.62. What is the ratio of the Gross enrolment ratio (%) of Pre-primary schools in Netherlands to that in New Zealand?
Give a very brief answer. 1.87. What is the ratio of the Gross enrolment ratio (%) in Primary schools in Netherlands to that in New Zealand?
Offer a very short reply. 0.83. What is the ratio of the Gross enrolment ratio (%) of Secondary schools in Netherlands to that in New Zealand?
Keep it short and to the point. 0.77. What is the ratio of the Gross enrolment ratio (%) of Tertiary schools in Netherlands to that in New Zealand?
Keep it short and to the point. 0.14. What is the difference between the highest and the second highest Gross enrolment ratio (%) in Pre-primary schools?
Keep it short and to the point. 34.33. What is the difference between the highest and the second highest Gross enrolment ratio (%) of Primary schools?
Your response must be concise. 26.92. What is the difference between the highest and the second highest Gross enrolment ratio (%) of Secondary schools?
Give a very brief answer. 6.44. What is the difference between the highest and the second highest Gross enrolment ratio (%) in Tertiary schools?
Provide a short and direct response. 21.75. What is the difference between the highest and the lowest Gross enrolment ratio (%) in Pre-primary schools?
Make the answer very short. 94.81. What is the difference between the highest and the lowest Gross enrolment ratio (%) of Primary schools?
Your answer should be very brief. 73.88. What is the difference between the highest and the lowest Gross enrolment ratio (%) of Secondary schools?
Give a very brief answer. 57.5. What is the difference between the highest and the lowest Gross enrolment ratio (%) of Tertiary schools?
Offer a terse response. 32.76. 